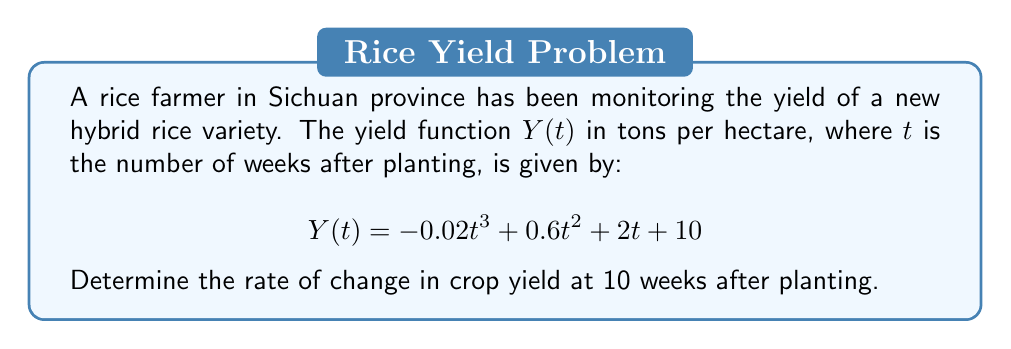Could you help me with this problem? To solve this problem, we need to find the derivative of the yield function and evaluate it at $t = 10$ weeks. This will give us the instantaneous rate of change in crop yield at that time.

1. First, let's find the derivative of $Y(t)$ with respect to $t$:
   $$Y'(t) = \frac{d}{dt}(-0.02t^3 + 0.6t^2 + 2t + 10)$$
   $$Y'(t) = -0.06t^2 + 1.2t + 2$$

2. Now that we have the derivative, we can evaluate it at $t = 10$:
   $$Y'(10) = -0.06(10)^2 + 1.2(10) + 2$$
   $$Y'(10) = -0.06(100) + 12 + 2$$
   $$Y'(10) = -6 + 12 + 2$$
   $$Y'(10) = 8$$

3. Interpret the result:
   The rate of change at 10 weeks after planting is 8 tons per hectare per week.

This positive value indicates that the crop yield is still increasing at this point, but the farmer should be aware that the rate of increase might slow down or even decrease in the future due to the negative cubic term in the original function.
Answer: The rate of change in crop yield at 10 weeks after planting is 8 tons per hectare per week. 